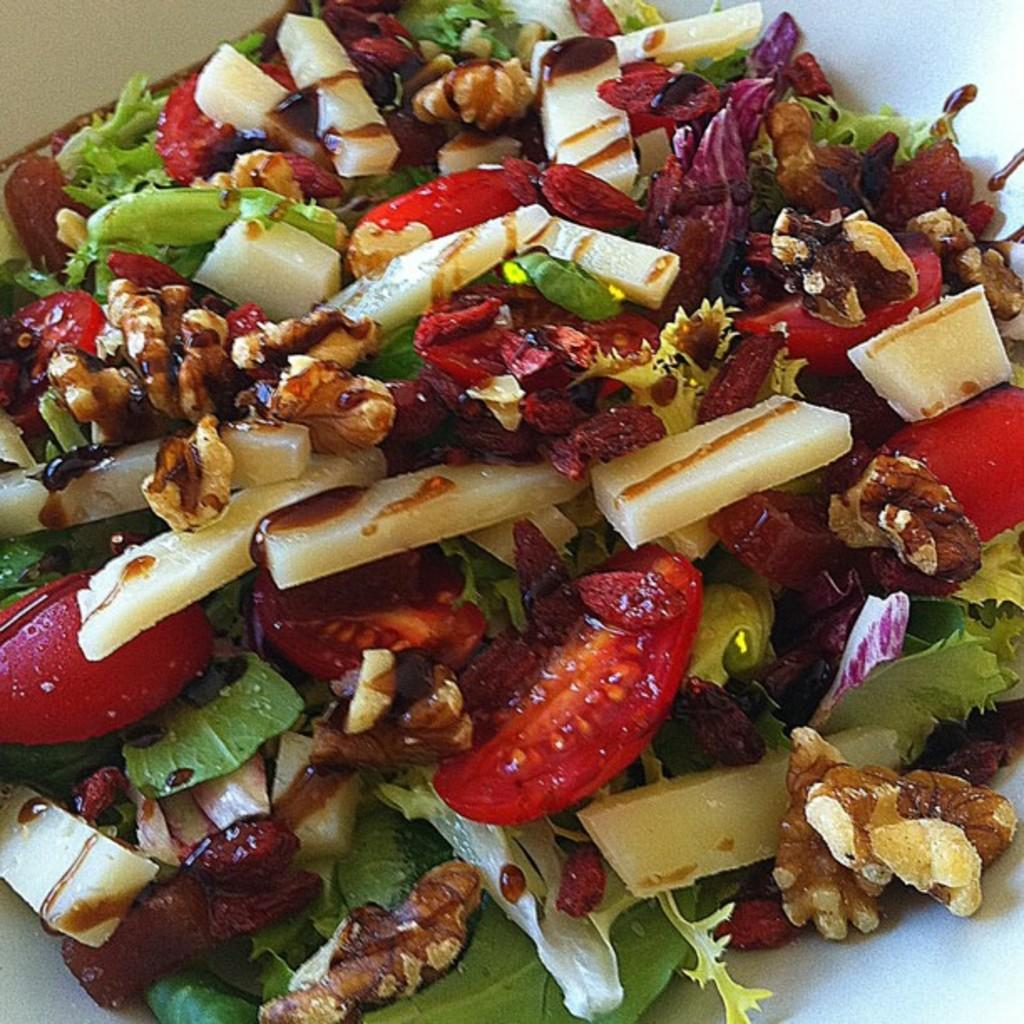What type of food can be seen in the image? There are cut fruits and vegetables in the image. What is the color of the surface on which the fruits and vegetables are placed? The fruits and vegetables are on a white surface. What force is being exerted on the vegetables in the image? There is no force being exerted on the vegetables in the image; they are simply placed on the white surface. Is there any exchange happening between the fruits and vegetables in the image? There is no exchange happening between the fruits and vegetables in the image; they are separate items on the white surface. 